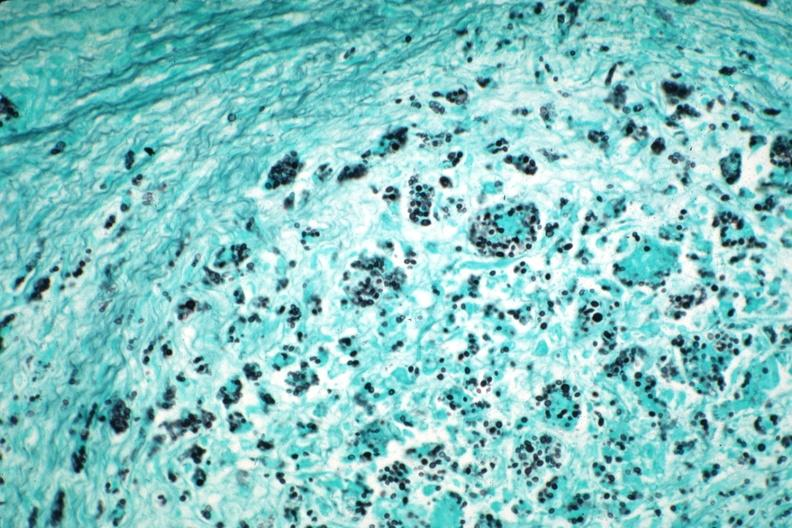s pneumocystis present?
Answer the question using a single word or phrase. Yes 